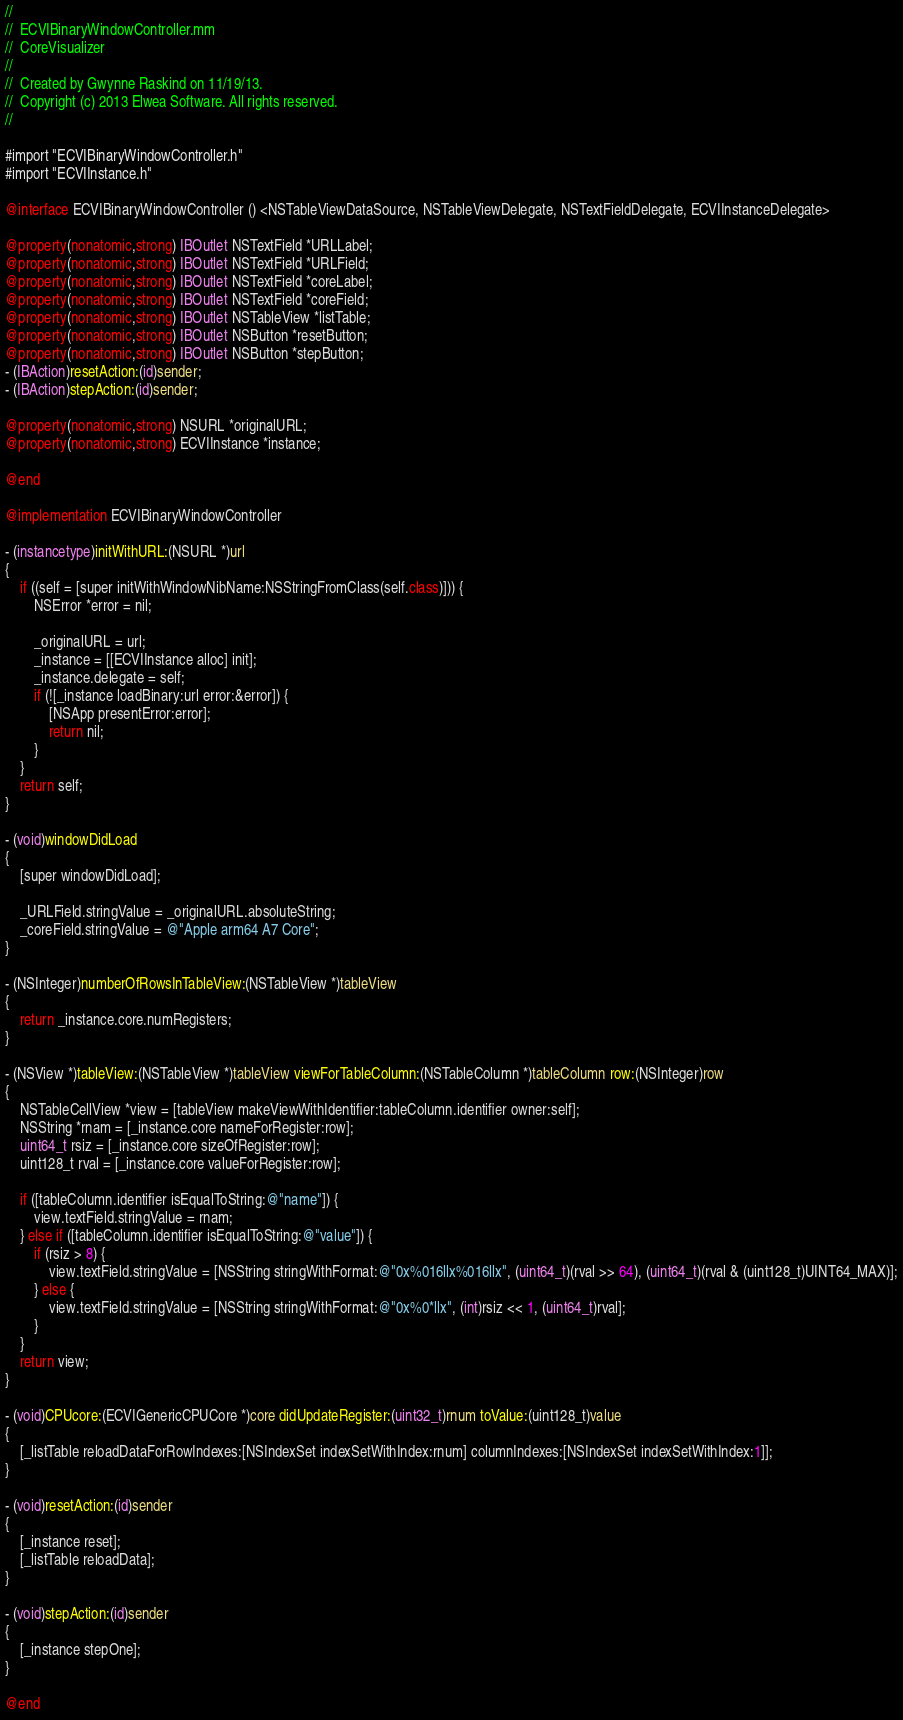<code> <loc_0><loc_0><loc_500><loc_500><_ObjectiveC_>//
//  ECVIBinaryWindowController.mm
//  CoreVisualizer
//
//  Created by Gwynne Raskind on 11/19/13.
//  Copyright (c) 2013 Elwea Software. All rights reserved.
//

#import "ECVIBinaryWindowController.h"
#import "ECVIInstance.h"

@interface ECVIBinaryWindowController () <NSTableViewDataSource, NSTableViewDelegate, NSTextFieldDelegate, ECVIInstanceDelegate>

@property(nonatomic,strong) IBOutlet NSTextField *URLLabel;
@property(nonatomic,strong) IBOutlet NSTextField *URLField;
@property(nonatomic,strong) IBOutlet NSTextField *coreLabel;
@property(nonatomic,strong) IBOutlet NSTextField *coreField;
@property(nonatomic,strong) IBOutlet NSTableView *listTable;
@property(nonatomic,strong) IBOutlet NSButton *resetButton;
@property(nonatomic,strong) IBOutlet NSButton *stepButton;
- (IBAction)resetAction:(id)sender;
- (IBAction)stepAction:(id)sender;

@property(nonatomic,strong) NSURL *originalURL;
@property(nonatomic,strong) ECVIInstance *instance;

@end

@implementation ECVIBinaryWindowController

- (instancetype)initWithURL:(NSURL *)url
{
	if ((self = [super initWithWindowNibName:NSStringFromClass(self.class)])) {
		NSError *error = nil;
		
		_originalURL = url;
		_instance = [[ECVIInstance alloc] init];
		_instance.delegate = self;
		if (![_instance loadBinary:url error:&error]) {
			[NSApp presentError:error];
			return nil;
		}
	}
	return self;
}

- (void)windowDidLoad
{
	[super windowDidLoad];
	
	_URLField.stringValue = _originalURL.absoluteString;
	_coreField.stringValue = @"Apple arm64 A7 Core";
}

- (NSInteger)numberOfRowsInTableView:(NSTableView *)tableView
{
	return _instance.core.numRegisters;
}

- (NSView *)tableView:(NSTableView *)tableView viewForTableColumn:(NSTableColumn *)tableColumn row:(NSInteger)row
{
	NSTableCellView *view = [tableView makeViewWithIdentifier:tableColumn.identifier owner:self];
	NSString *rnam = [_instance.core nameForRegister:row];
	uint64_t rsiz = [_instance.core sizeOfRegister:row];
	uint128_t rval = [_instance.core valueForRegister:row];
	
	if ([tableColumn.identifier isEqualToString:@"name"]) {
		view.textField.stringValue = rnam;
	} else if ([tableColumn.identifier isEqualToString:@"value"]) {
		if (rsiz > 8) {
			view.textField.stringValue = [NSString stringWithFormat:@"0x%016llx%016llx", (uint64_t)(rval >> 64), (uint64_t)(rval & (uint128_t)UINT64_MAX)];
		} else {
			view.textField.stringValue = [NSString stringWithFormat:@"0x%0*llx", (int)rsiz << 1, (uint64_t)rval];
		}
	}
	return view;
}

- (void)CPUcore:(ECVIGenericCPUCore *)core didUpdateRegister:(uint32_t)rnum toValue:(uint128_t)value
{
	[_listTable reloadDataForRowIndexes:[NSIndexSet indexSetWithIndex:rnum] columnIndexes:[NSIndexSet indexSetWithIndex:1]];
}

- (void)resetAction:(id)sender
{
	[_instance reset];
	[_listTable reloadData];
}

- (void)stepAction:(id)sender
{
	[_instance stepOne];
}

@end
</code> 